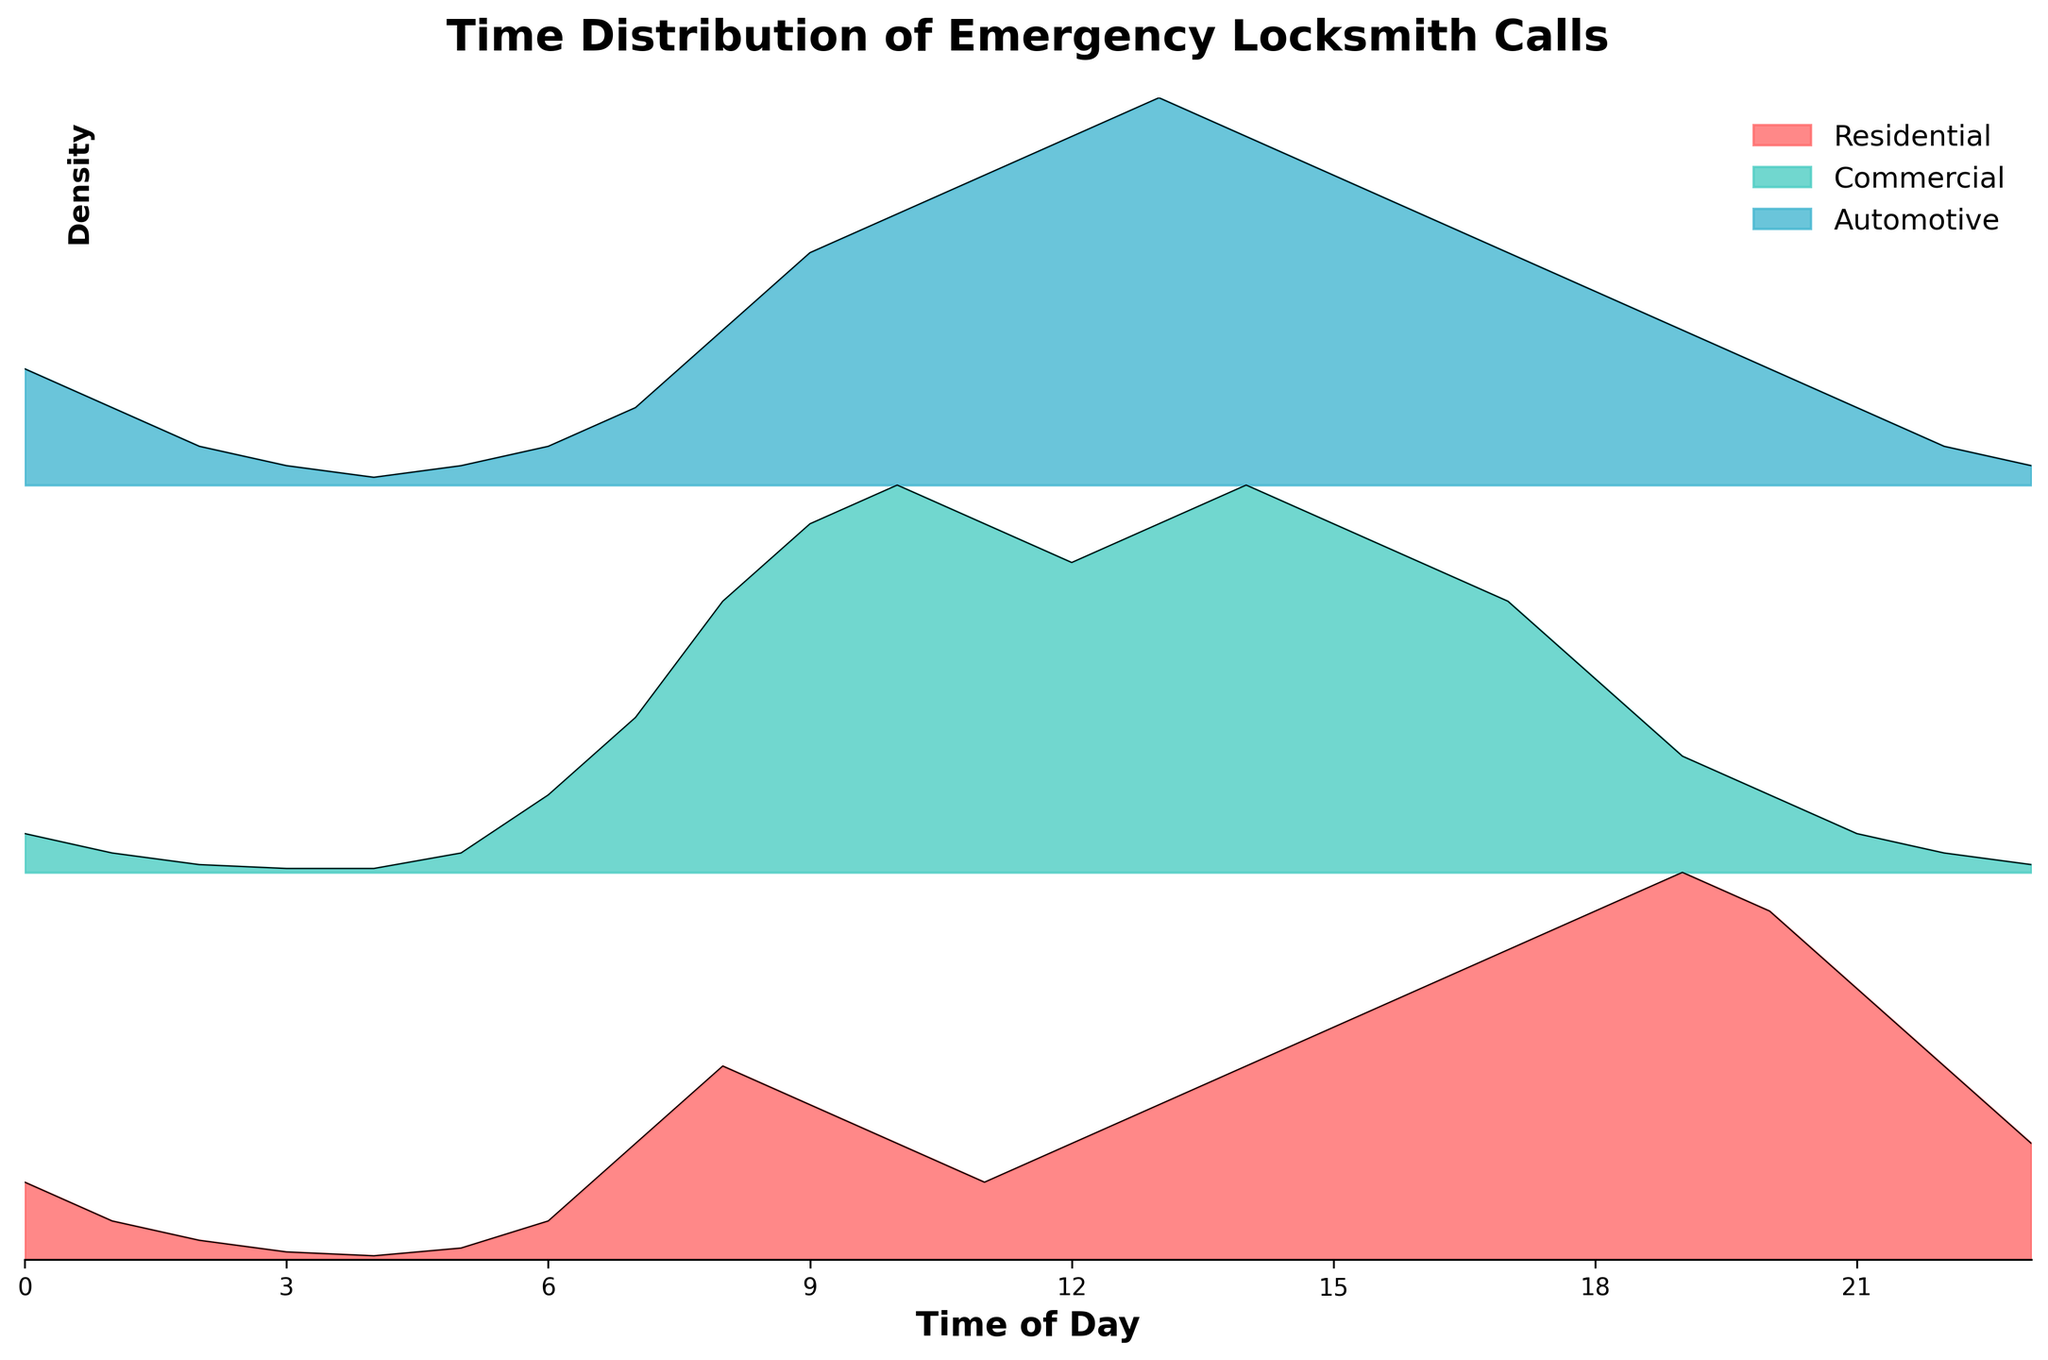What is the title of the figure? The title is usually located at the top of the figure and summarizes the main content. In this case, it reads "Time Distribution of Emergency Locksmith Calls."
Answer: Time Distribution of Emergency Locksmith Calls What categories are compared in the plot? The categories are identified by their labels in the legend or captions within the figure. Here, three categories are compared: Residential, Commercial, and Automotive.
Answer: Residential, Commercial, Automotive Which category has the highest density of emergency locksmith calls around 10:00 (10 AM)? By examining the plot at the time mark of 10, the category with the highest peak among the three at this time is found. For 10:00, the Commercial category reaches its peak density of 1.0.
Answer: Commercial At what time does the density of emergency locksmith calls peak for the Automotive category? For the Automotive category, locate its highest point on the y-axis across the 24-hour timeline. The peak density of 1.0 occurs at 13:00 (1 PM).
Answer: 13:00 or 1 PM Which category has a consistently low density of calls during early morning hours (0:00 - 4:00 AM)? Reviewing the density lines for each category between 0:00 and 4:00, the Commercial category shows consistently low values compared to Residential and Automotive.
Answer: Commercial During which time range do Residential and Automotive categories show overlapping peak densities? Find periods where the peak densities of Residential and Automotive categories occur simultaneously or closely. Both categories show high densities between 12:00 and 15:00 (noon to 3 PM).
Answer: 12:00 - 15:00 or noon to 3 PM At what time does the Residential category reach its highest density of emergency locksmith calls? Inspect the line representing the Residential category to find its highest point. The peak density of 1.0 for Residential occurs at 19:00 (7 PM).
Answer: 19:00 or 7 PM How does the density of emergency locksmith calls for Commercial and Residential categories compare at 8:00 (8 AM)? Compare the heights of the densities for Commercial and Residential at the 8:00 mark. Commercial has a density of 0.7, while Residential has a density of 0.5. The Commercial category is higher.
Answer: Commercial > Residential Which category has the least variation in density throughout the entire day? Identify the category with the most stable line with the smallest fluctuations over 24 hours. Commercial shows the least variation, staying consistently low through early hours and peaking around midday.
Answer: Commercial 